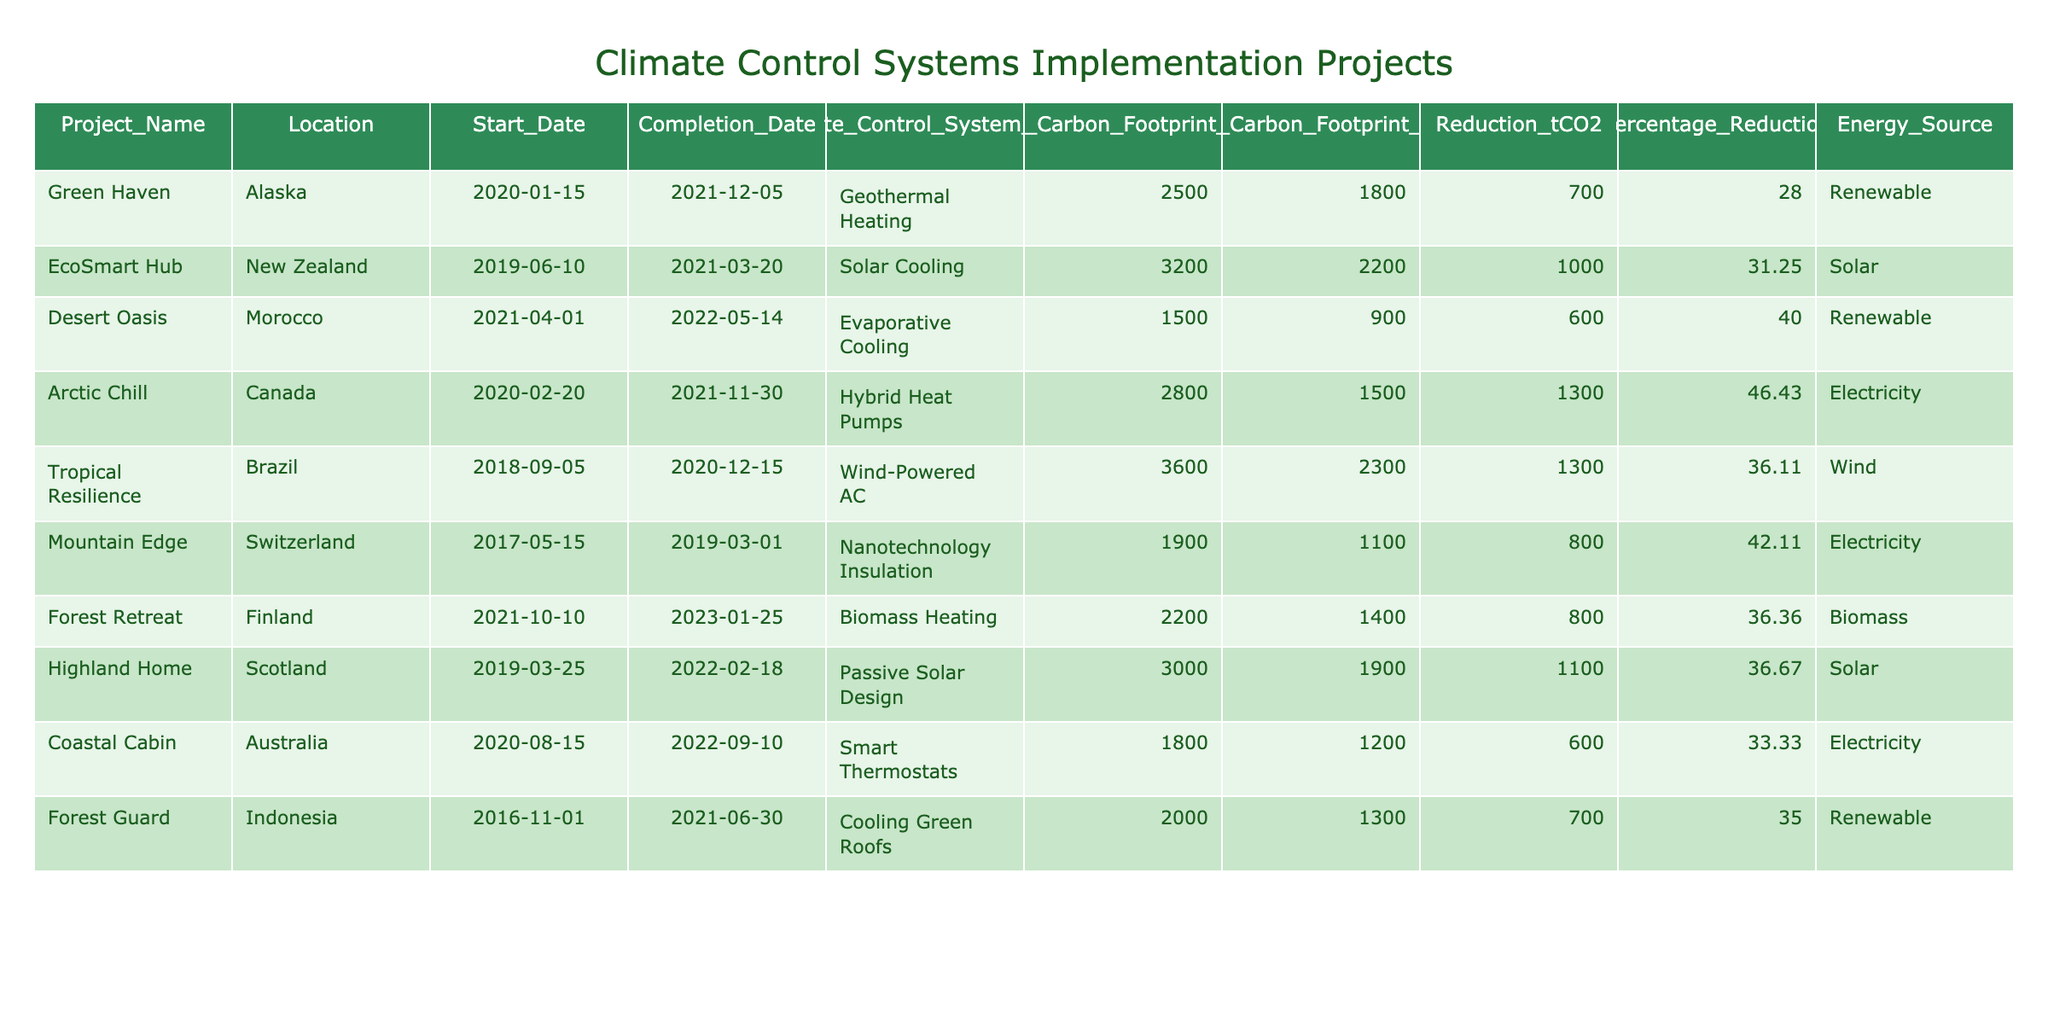What is the total carbon footprint reduction achieved across all projects? To find the total reduction, add the reduction values: 700 + 1000 + 600 + 1300 + 1300 + 800 + 800 + 1100 + 600 + 700 = 6100 tCO2.
Answer: 6100 tCO2 Which project achieved the highest percentage reduction in carbon footprint? Check the "Percentage Reduction" column for the highest value: Arctic Chill at 46.43% has the highest percentage reduction.
Answer: Arctic Chill How many projects used renewable energy sources? By examining the "Energy Source" column, the projects using renewable sources are: Green Haven, Desert Oasis, Forest Guard. This totals to 3 projects.
Answer: 3 projects What is the average initial carbon footprint of the projects listed? Calculate the average by summing the initial footprints: (2500 + 3200 + 1500 + 2800 + 3600 + 1900 + 2200 + 3000 + 1800 + 2000) = 22500, then divide by 10 projects: 22500 / 10 = 2250 tCO2.
Answer: 2250 tCO2 Is there any project that reduced its carbon footprint by more than 1000 tCO2? Check the "Reduction_tCO2" values for any over 1000 tCO2. The projects Arctic Chill and Tropical Resilience both have reductions of 1300 tCO2. Yes, there are projects that achieved this.
Answer: Yes What is the difference in final carbon footprint between the project with the highest and the lowest final footprint? Identify the highest final footprint (Arctic Chill, 1500 tCO2) and the lowest (Desert Oasis, 900 tCO2). The difference is 1500 - 900 = 600 tCO2.
Answer: 600 tCO2 Which climate control system type had the most effective reduction percentage, and what was that percentage? Assess the percentage reductions: Arctic Chill (46.43%), Desert Oasis (40%), Mountain Edge (42.11%). Arctic Chill has the highest at 46.43%.
Answer: 46.43% How many projects took longer than two years from start to completion? Check the "Start Date" and "Completion Date" for duration. Only EcoSmart Hub (June 2019 to March 2021) and Highland Home (March 2019 to February 2022) exceed two years, totaling 2 projects.
Answer: 2 projects Which location had the lowest initial carbon footprint? Look for the minimum value in the "Initial Carbon Footprint" column. The project Desert Oasis in Morocco had the lowest initial footprint of 1500 tCO2.
Answer: Desert Oasis Were there any projects that used solar energy systems? Inspect the "Energy Source" column. The projects EcoSmart Hub and Highland Home both relied on solar energy systems.
Answer: Yes What is the percentage reduction achieved by the Forest Retreat project? Check the "Percentage Reduction" column for Forest Retreat. It shows a reduction of 36.36%.
Answer: 36.36% 